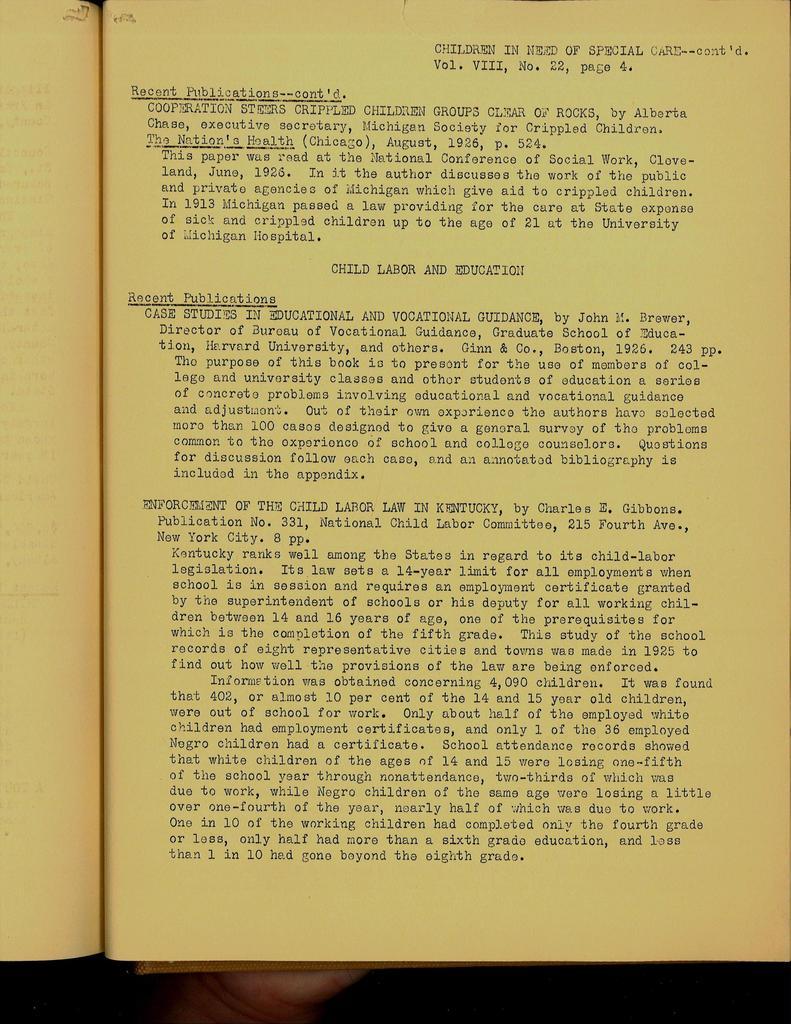What volume is this?
Offer a terse response. Viii. 